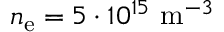Convert formula to latex. <formula><loc_0><loc_0><loc_500><loc_500>n _ { e } = 5 \cdot 1 0 ^ { 1 5 } m ^ { - 3 }</formula> 